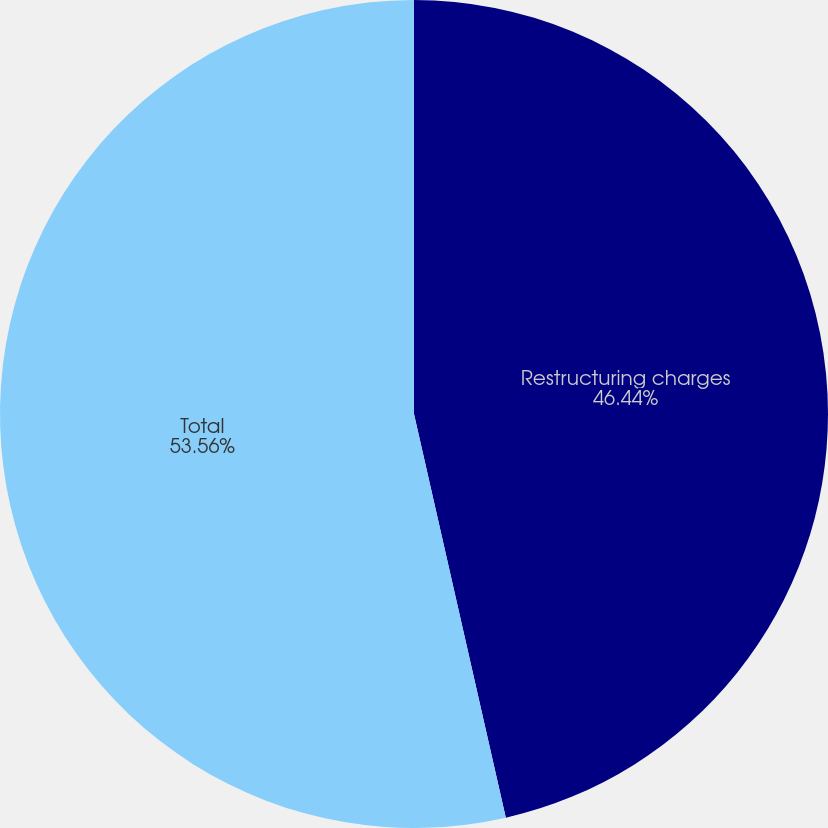Convert chart to OTSL. <chart><loc_0><loc_0><loc_500><loc_500><pie_chart><fcel>Restructuring charges<fcel>Total<nl><fcel>46.44%<fcel>53.56%<nl></chart> 